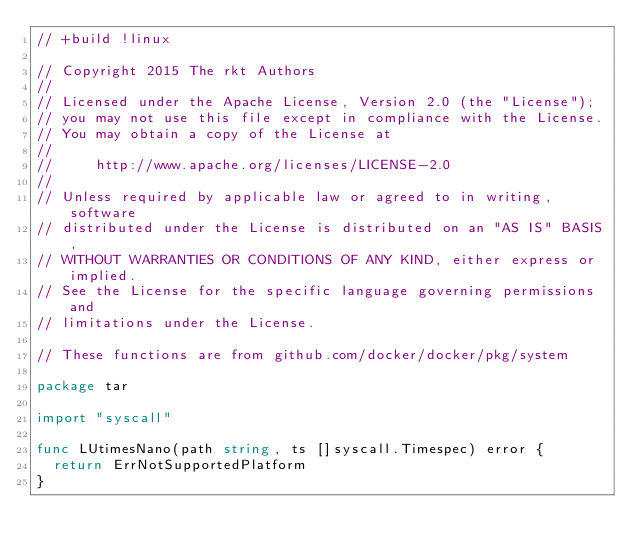<code> <loc_0><loc_0><loc_500><loc_500><_Go_>// +build !linux

// Copyright 2015 The rkt Authors
//
// Licensed under the Apache License, Version 2.0 (the "License");
// you may not use this file except in compliance with the License.
// You may obtain a copy of the License at
//
//     http://www.apache.org/licenses/LICENSE-2.0
//
// Unless required by applicable law or agreed to in writing, software
// distributed under the License is distributed on an "AS IS" BASIS,
// WITHOUT WARRANTIES OR CONDITIONS OF ANY KIND, either express or implied.
// See the License for the specific language governing permissions and
// limitations under the License.

// These functions are from github.com/docker/docker/pkg/system

package tar

import "syscall"

func LUtimesNano(path string, ts []syscall.Timespec) error {
	return ErrNotSupportedPlatform
}
</code> 